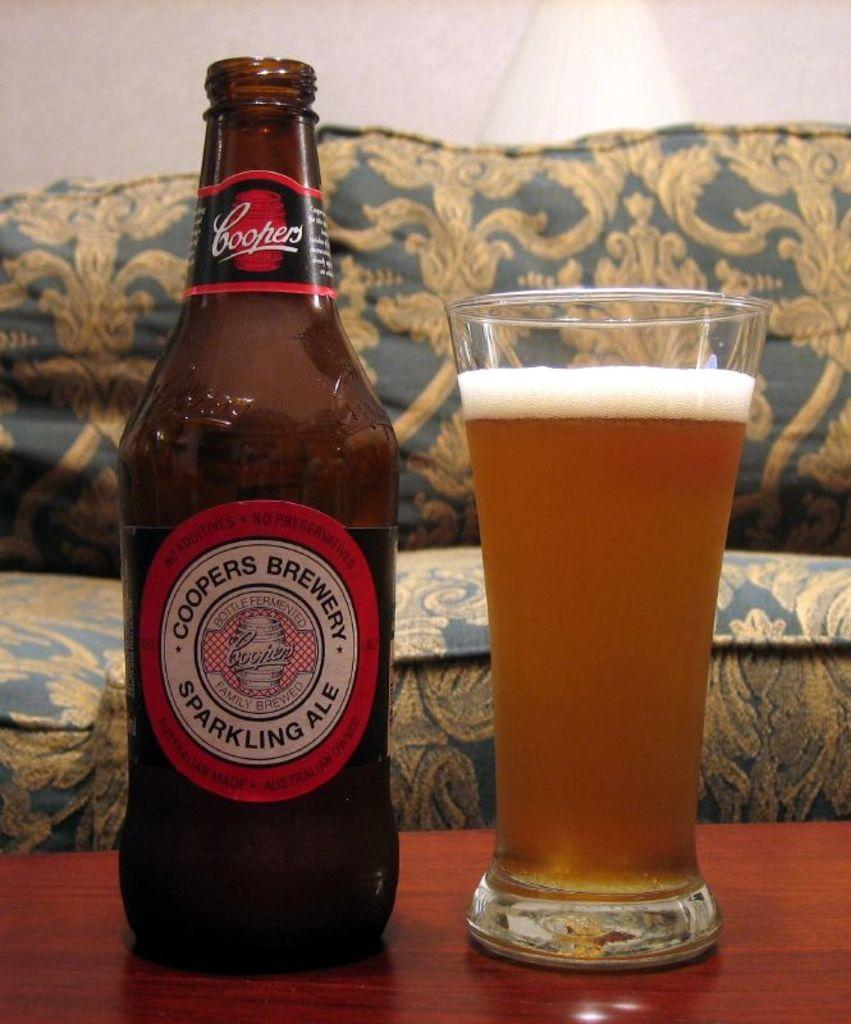<image>
Summarize the visual content of the image. Bottle of Coopers Brewery Sparkling Ale next to a full cup of beer. 